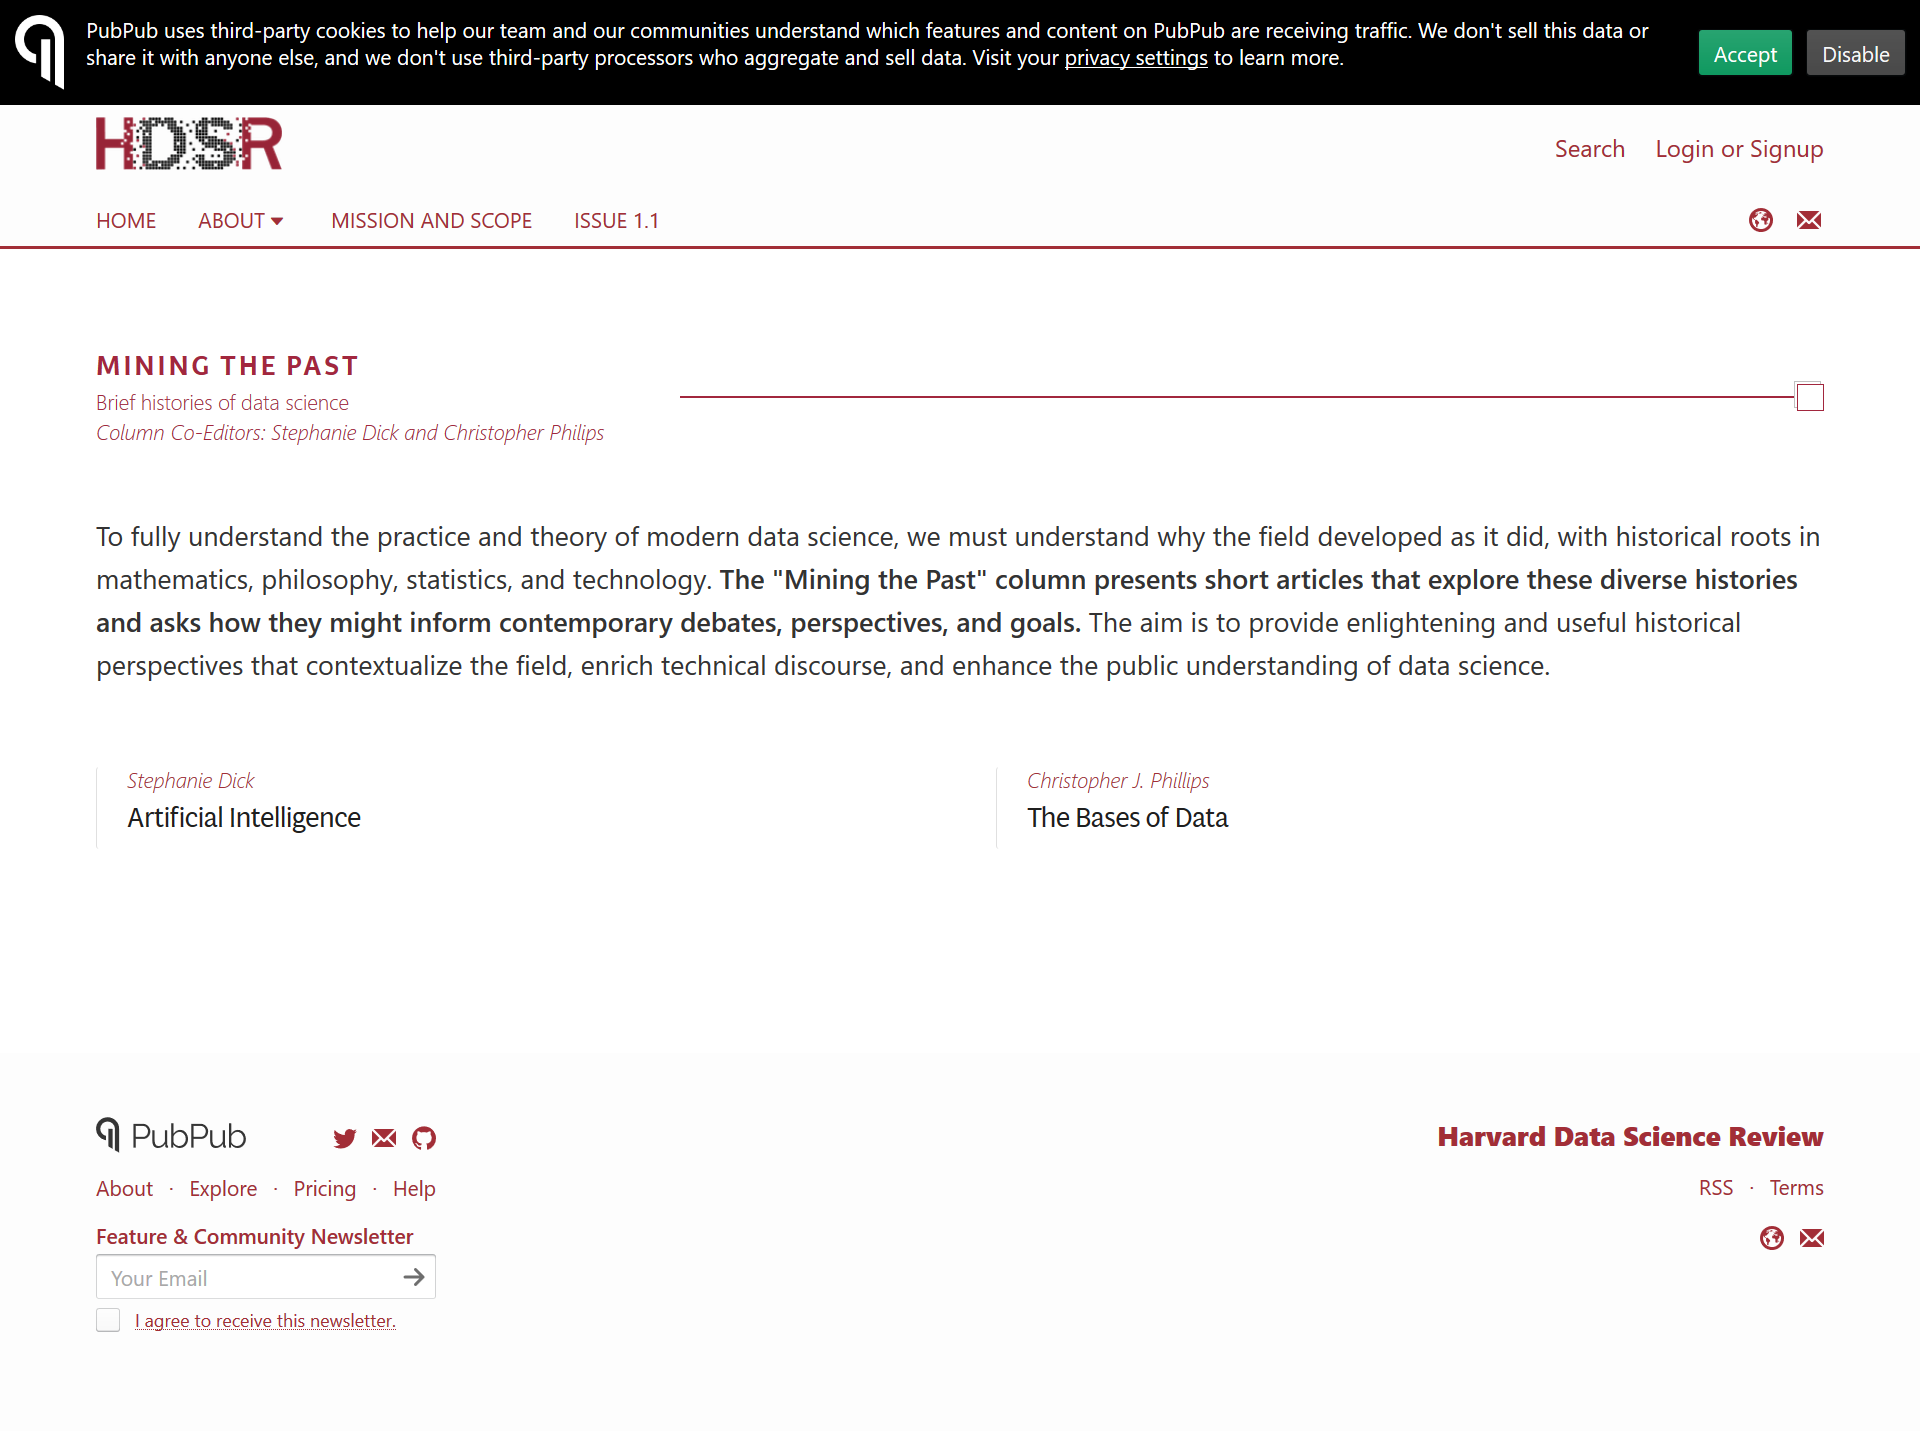Highlight a few significant elements in this photo. Chris Phillips' field is based on the foundations of data. The areas of mathematics, philosophy, statistics, and technology are historically rooted in the development of data science. Stephanie Dick and Christopher Phillips are the co-authors of this article. 